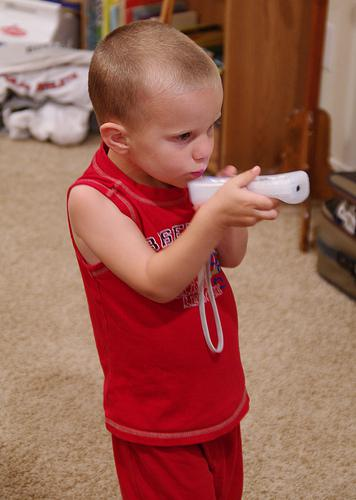Question: where is the game controller?
Choices:
A. On the table.
B. In the boy's hand.
C. Beside the girl.
D. On the tv stand.
Answer with the letter. Answer: B Question: why is the boy holding the white device?
Choices:
A. To play a game.
B. To take a picture.
C. To talk on.
D. To record something.
Answer with the letter. Answer: A 